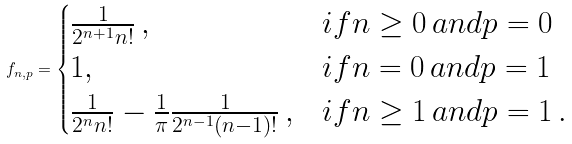Convert formula to latex. <formula><loc_0><loc_0><loc_500><loc_500>f _ { n , p } = \begin{cases} \frac { 1 } { 2 ^ { n + 1 } n ! } \, , & i f n \geq 0 \, a n d p = 0 \\ 1 , & i f n = 0 \, a n d p = 1 \\ \frac { 1 } { 2 ^ { n } n ! } - \frac { 1 } { \pi } \frac { 1 } { 2 ^ { n - 1 } ( n - 1 ) ! } \, , & i f n \geq 1 \, a n d p = 1 \, . \end{cases}</formula> 